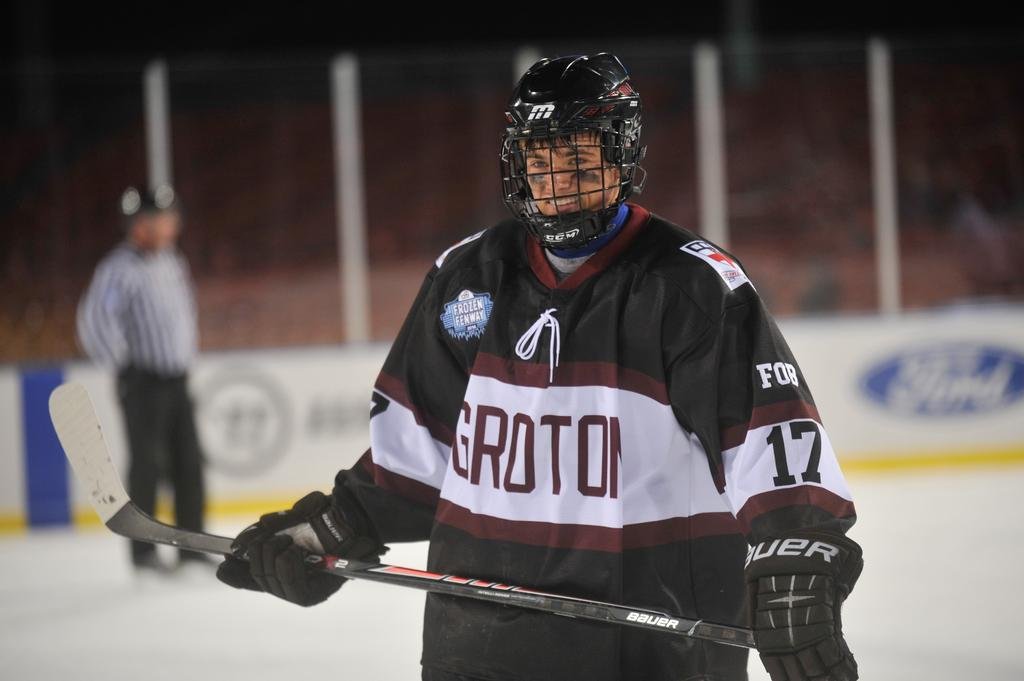Who is present in the image? There is a man in the image. What is the man doing in the image? The man is standing in the image. What is the man wearing in the image? The man is wearing a jersey and a helmet in the image. What is the man holding in the image? The man is holding a hockey stick in the image. What can be seen in the background of the image? There are empty chairs in the background of the image. What type of cannon is the man using to play the game in the image? There is no cannon present in the image; the man is holding a hockey stick. Who is the man's friend in the image? The image does not show any other people besides the man, so it is not possible to determine if he has a friend in the image. 